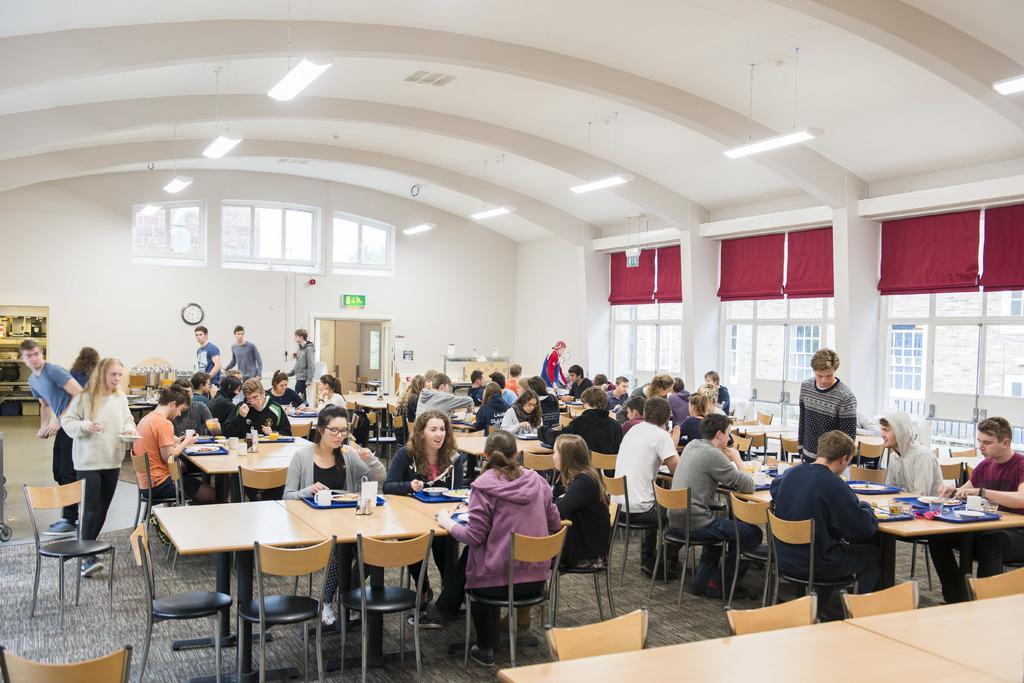Can you describe this image briefly? In this image I can see a group of people sitting on the chairs. This is a table. On this I can see a tray,mug plate and some objects are placed on it. I can see some empty chairs. At background I can see a wall clock attached to the wall. This is a window,and this is a light hanging to the rooftop. I can see some people standing. At the right side of the image I can see a red color curtain hanging. At background I can see another room. 